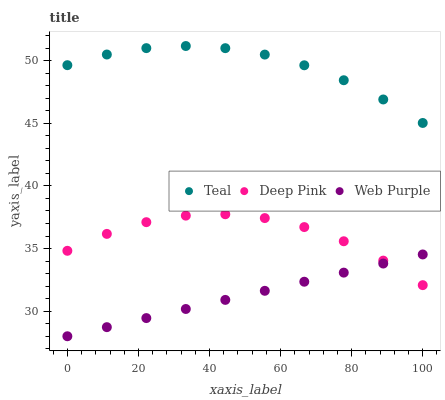Does Web Purple have the minimum area under the curve?
Answer yes or no. Yes. Does Teal have the maximum area under the curve?
Answer yes or no. Yes. Does Deep Pink have the minimum area under the curve?
Answer yes or no. No. Does Deep Pink have the maximum area under the curve?
Answer yes or no. No. Is Web Purple the smoothest?
Answer yes or no. Yes. Is Deep Pink the roughest?
Answer yes or no. Yes. Is Teal the smoothest?
Answer yes or no. No. Is Teal the roughest?
Answer yes or no. No. Does Web Purple have the lowest value?
Answer yes or no. Yes. Does Deep Pink have the lowest value?
Answer yes or no. No. Does Teal have the highest value?
Answer yes or no. Yes. Does Deep Pink have the highest value?
Answer yes or no. No. Is Deep Pink less than Teal?
Answer yes or no. Yes. Is Teal greater than Web Purple?
Answer yes or no. Yes. Does Deep Pink intersect Web Purple?
Answer yes or no. Yes. Is Deep Pink less than Web Purple?
Answer yes or no. No. Is Deep Pink greater than Web Purple?
Answer yes or no. No. Does Deep Pink intersect Teal?
Answer yes or no. No. 